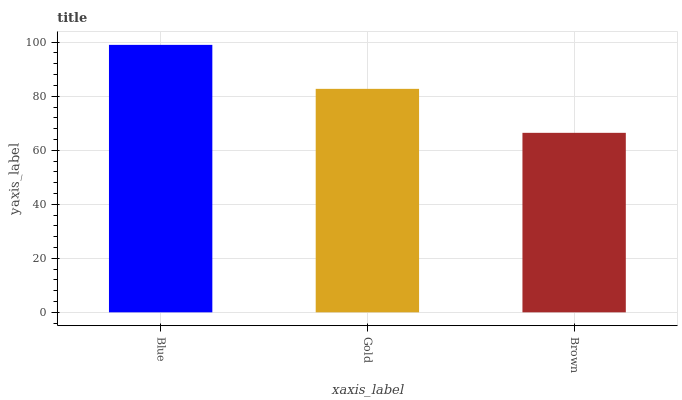Is Brown the minimum?
Answer yes or no. Yes. Is Blue the maximum?
Answer yes or no. Yes. Is Gold the minimum?
Answer yes or no. No. Is Gold the maximum?
Answer yes or no. No. Is Blue greater than Gold?
Answer yes or no. Yes. Is Gold less than Blue?
Answer yes or no. Yes. Is Gold greater than Blue?
Answer yes or no. No. Is Blue less than Gold?
Answer yes or no. No. Is Gold the high median?
Answer yes or no. Yes. Is Gold the low median?
Answer yes or no. Yes. Is Blue the high median?
Answer yes or no. No. Is Brown the low median?
Answer yes or no. No. 